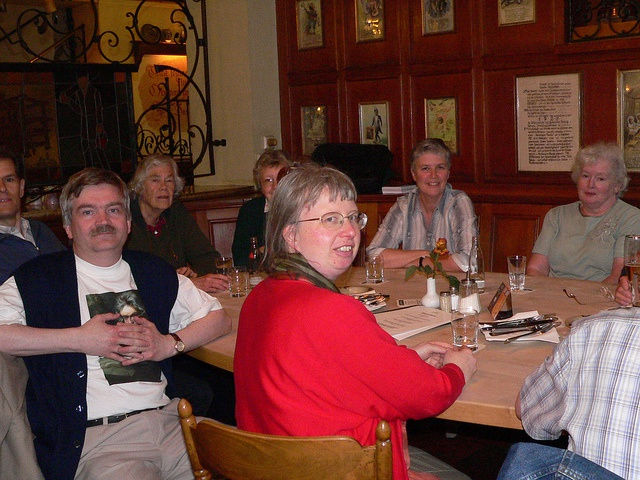Describe the objects in this image and their specific colors. I can see people in black, brown, darkgray, and lightgray tones, people in black, red, brown, and salmon tones, dining table in black, brown, and maroon tones, people in black, lightgray, darkgray, and gray tones, and chair in black, maroon, and brown tones in this image. 